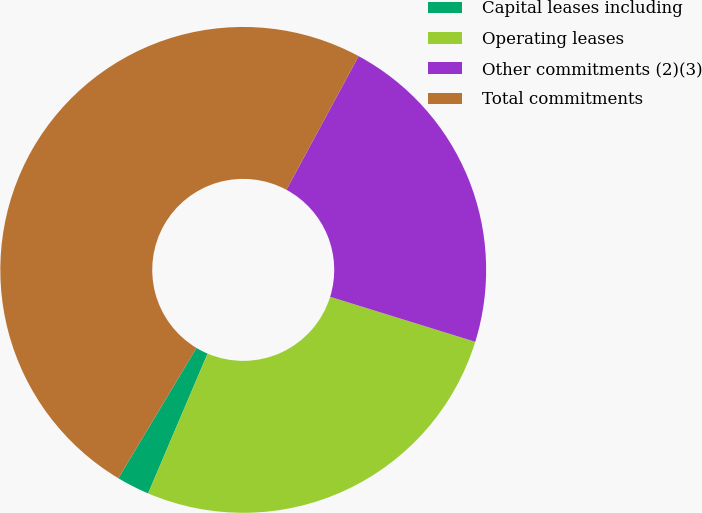Convert chart to OTSL. <chart><loc_0><loc_0><loc_500><loc_500><pie_chart><fcel>Capital leases including<fcel>Operating leases<fcel>Other commitments (2)(3)<fcel>Total commitments<nl><fcel>2.19%<fcel>26.62%<fcel>21.91%<fcel>49.29%<nl></chart> 